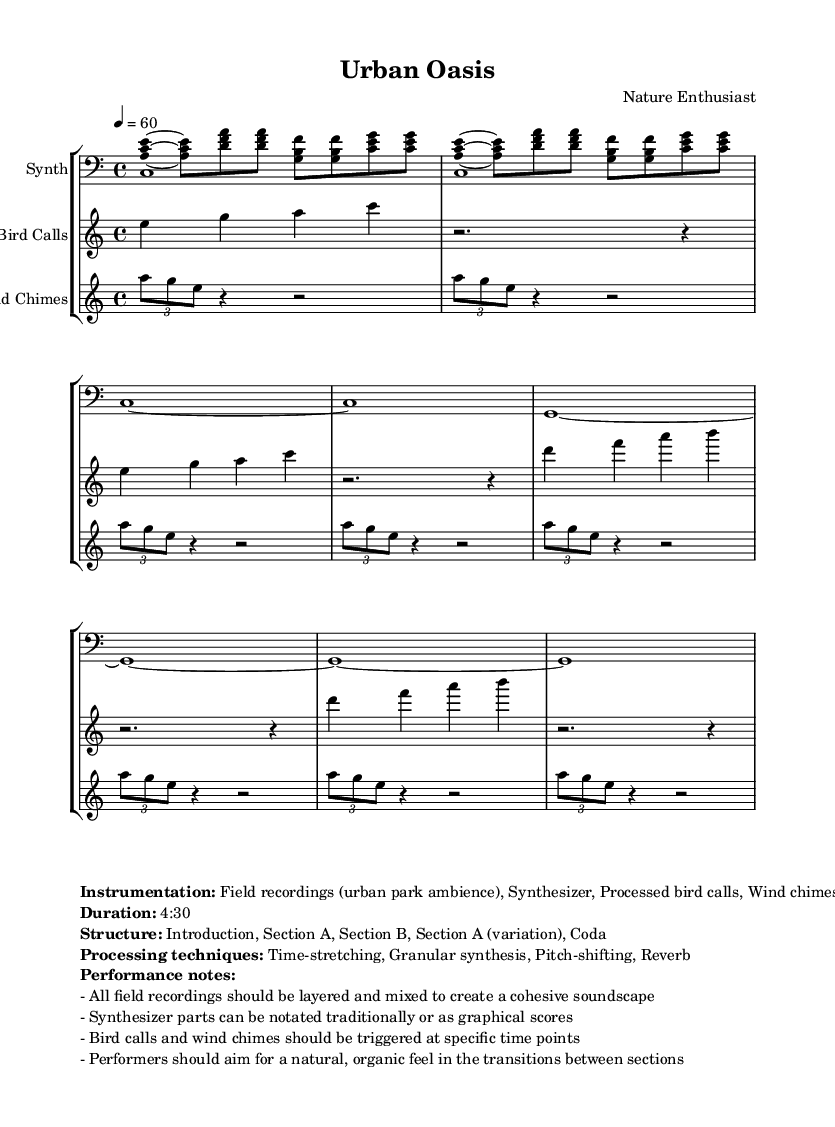What is the time signature of this music? The time signature is noted at the beginning of the piece and is written as 4/4, indicating four beats per measure.
Answer: 4/4 What is the tempo marking of this piece? The tempo marking is specified with "4 = 60," which indicates that there are 60 beats per minute, corresponding to the quarter note.
Answer: 60 How many sections are in the structure of this piece? The structure is described in the markup as having five sections: Introduction, Section A, Section B, Section A (variation), and Coda.
Answer: Five What techniques are used for processing the field recordings? The processing techniques listed in the markup include time-stretching, granular synthesis, pitch-shifting, and reverb.
Answer: Time-stretching, granular synthesis, pitch-shifting, reverb What instruments are used in this composition? The instrumentation as stated includes field recordings (urban park ambience), synthesizer, processed bird calls, and wind chimes.
Answer: Field recordings, Synthesizer, Processed bird calls, Wind chimes What is the duration of the piece? The duration is provided in the markup as 4:30, meaning the piece lasts four minutes and thirty seconds.
Answer: 4:30 What performance note emphasizes the transition between sections? The performance note indicates that performers should aim for a natural, organic feel in the transitions between sections, promoting fluidity in the presentation.
Answer: Natural, organic feel 